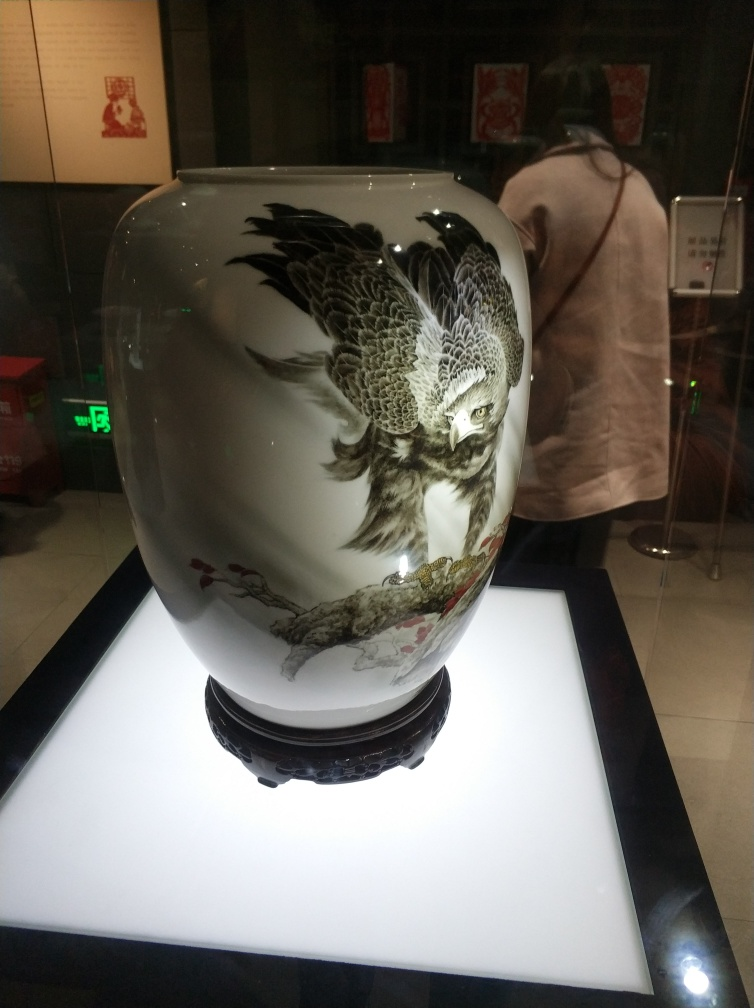How would this vase have been created, in terms of artistic technique? This type of vase is likely the result of a complex, multi-step process that combines both pottery and painting skills. The vase itself is first shaped and fired by a potter. Once the basic form is complete and the vase is glazed, an artist paints the intricate designs onto the surface. This requires a steady hand and a deep understanding of the glaze's chemistry, as the colors can change during the firing process. The owl and surrounding foliage may have been painted using fine brushes with natural bristles, allowing for the detailed lines and subtle shading we see. After painting, the vase is fired again to set the artwork permanently into the glaze. 